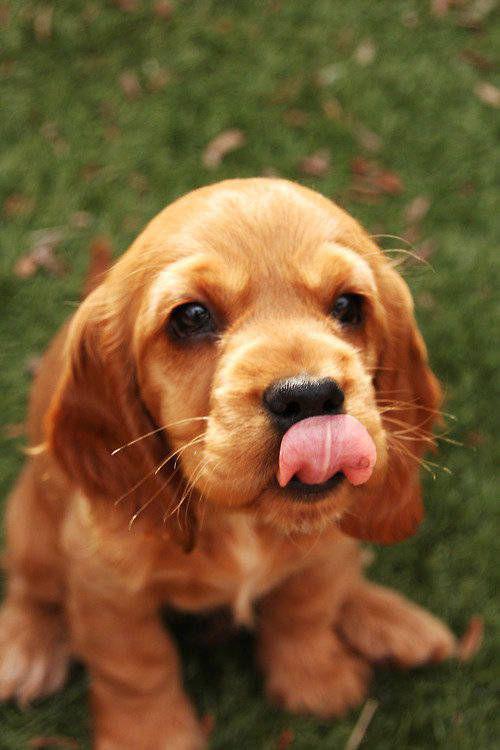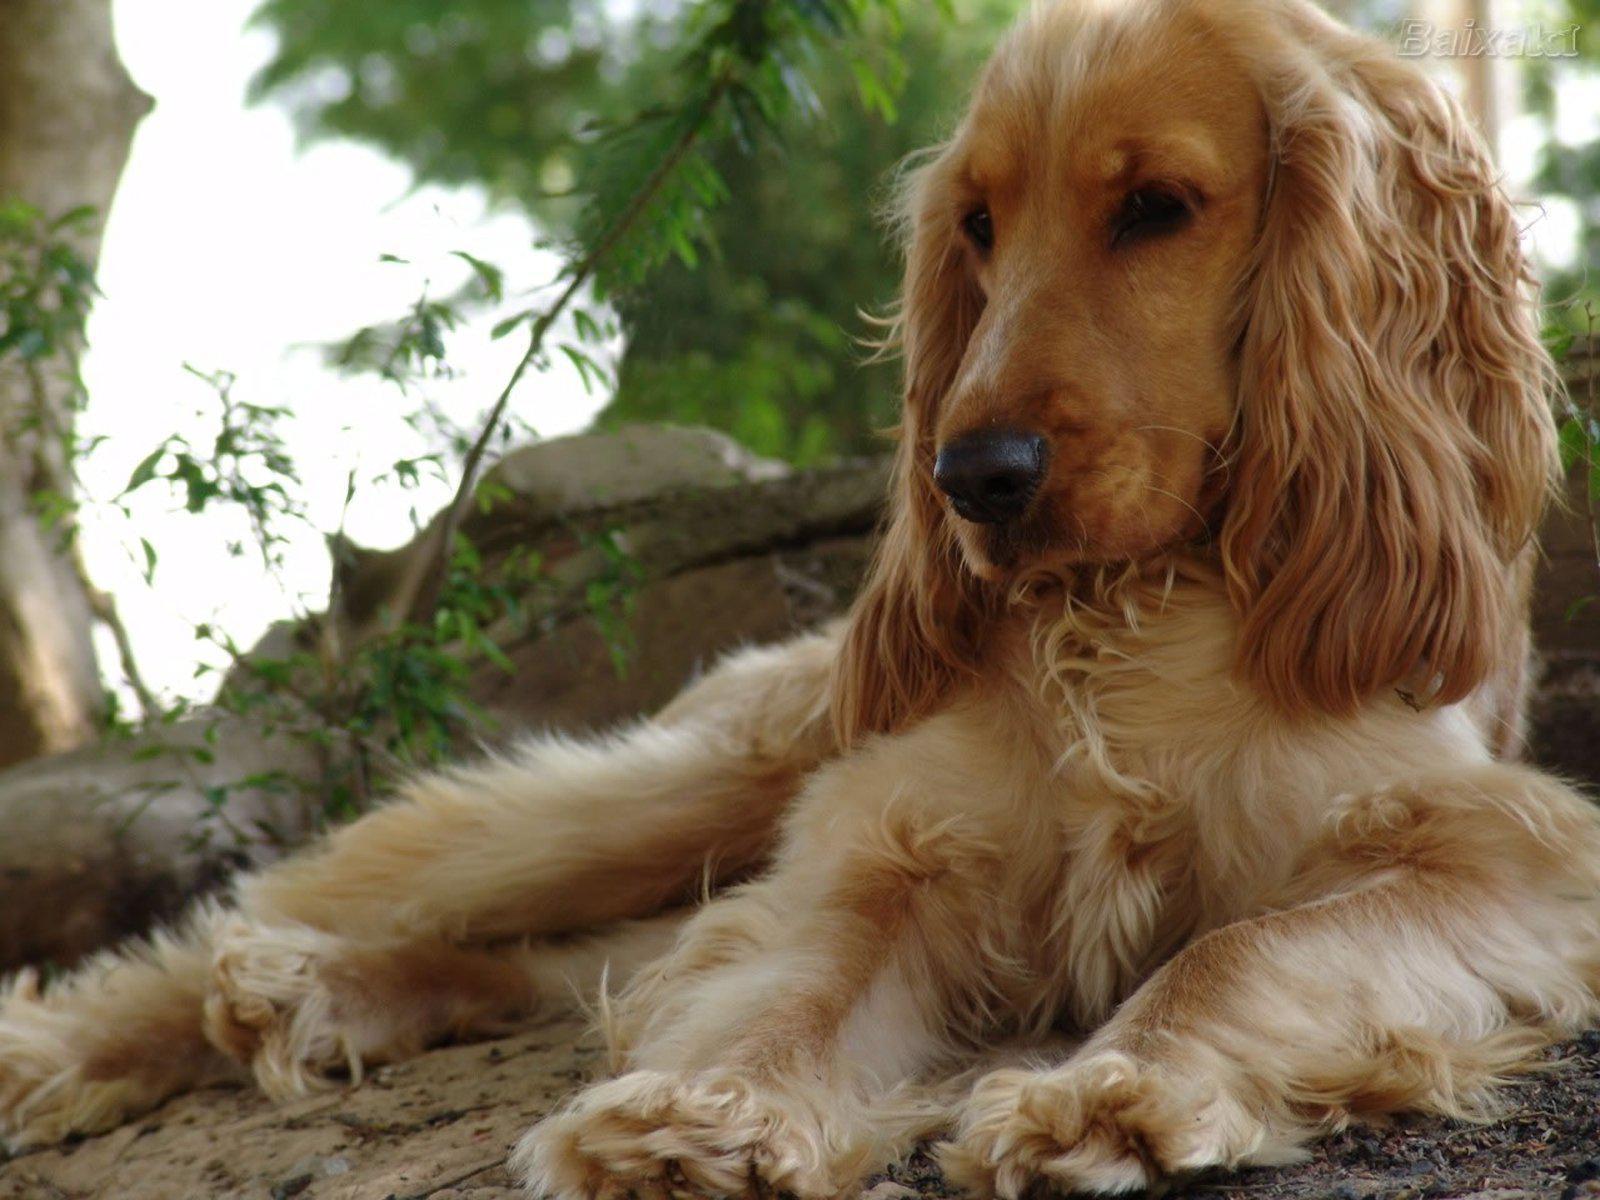The first image is the image on the left, the second image is the image on the right. Analyze the images presented: Is the assertion "An upright cocket spaniel is outdoors and has its tongue extended but not licking its nose." valid? Answer yes or no. No. The first image is the image on the left, the second image is the image on the right. Considering the images on both sides, is "A single dog is on grass" valid? Answer yes or no. Yes. 